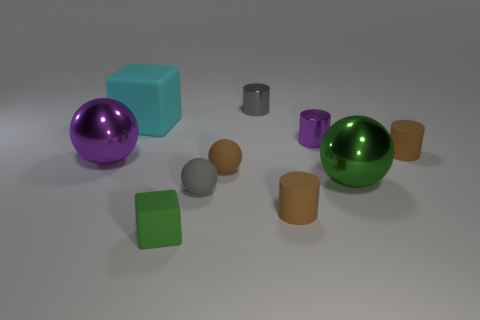Subtract all cylinders. How many objects are left? 6 Subtract all cylinders. Subtract all brown balls. How many objects are left? 5 Add 6 rubber spheres. How many rubber spheres are left? 8 Add 7 cyan blocks. How many cyan blocks exist? 8 Subtract 1 purple balls. How many objects are left? 9 